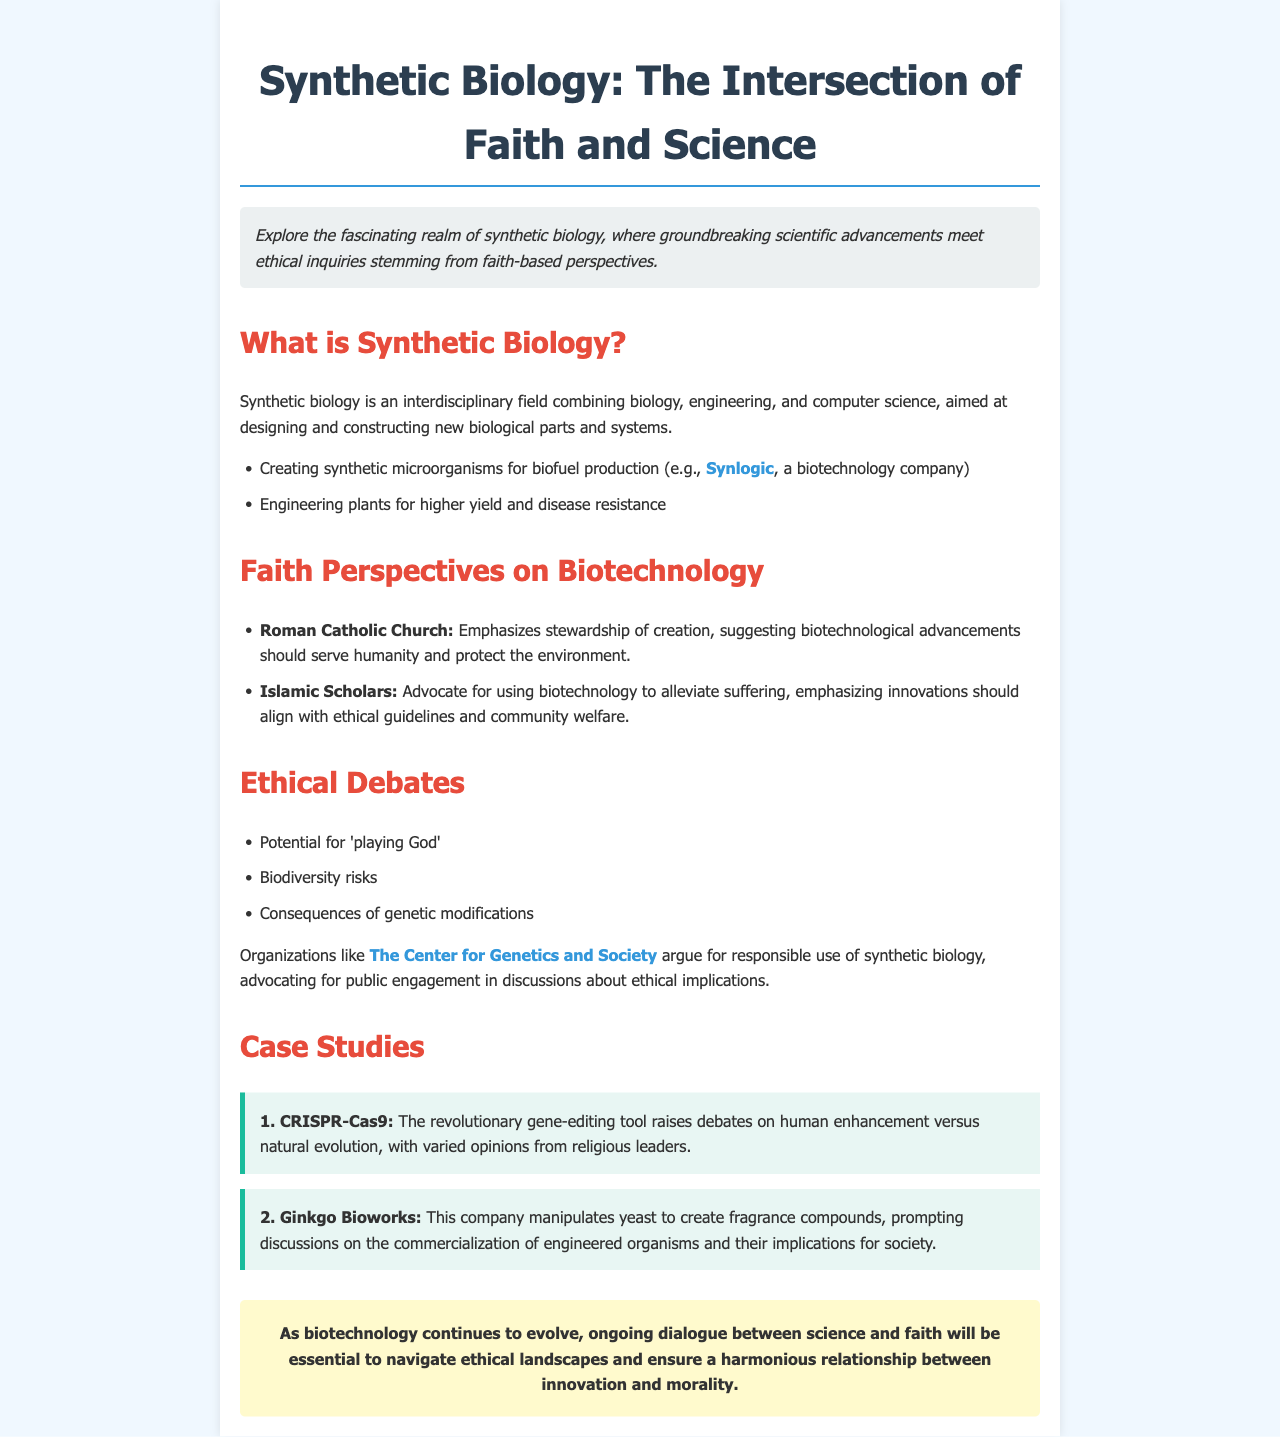What is synthetic biology? Synthetic biology is defined in the document as an interdisciplinary field combining biology, engineering, and computer science, aimed at designing and constructing new biological parts and systems.
Answer: An interdisciplinary field What is one application of synthetic biology mentioned? The document lists creating synthetic microorganisms for biofuel production as an application of synthetic biology.
Answer: Biofuel production Which church emphasizes stewardship of creation? The document specifically mentions the Roman Catholic Church regarding its perspective on biotechnology and stewardship.
Answer: Roman Catholic Church What tool raises debates on human enhancement? The document states that CRISPR-Cas9 raises debates on human enhancement versus natural evolution.
Answer: CRISPR-Cas9 What organization advocates for responsible use of synthetic biology? The Center for Genetics and Society is mentioned as advocating for responsible use of synthetic biology in the document.
Answer: The Center for Genetics and Society What are two ethical debates mentioned? The document provides potential ethical debates, including playing God and biodiversity risks.
Answer: Playing God; biodiversity risks What color is used for the heading "Faith Perspectives on Biotechnology"? The document describes the color used for the heading as red.
Answer: Red What is the conclusion's focus in regard to biotechnology and faith? The conclusion emphasizes the need for ongoing dialogue between science and faith to navigate ethical landscapes.
Answer: Ongoing dialogue 